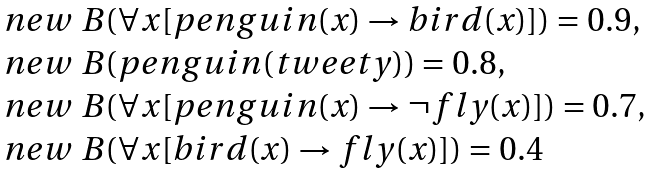<formula> <loc_0><loc_0><loc_500><loc_500>\begin{array} { l } n e w \ B ( \forall x [ p e n g u i n ( x ) \rightarrow b i r d ( x ) ] ) = 0 . 9 , \\ n e w \ B ( p e n g u i n ( t w e e t y ) ) = 0 . 8 , \\ n e w \ B ( \forall x [ p e n g u i n ( x ) \rightarrow \neg f l y ( x ) ] ) = 0 . 7 , \\ n e w \ B ( \forall x [ b i r d ( x ) \rightarrow f l y ( x ) ] ) = 0 . 4 \\ \end{array}</formula> 